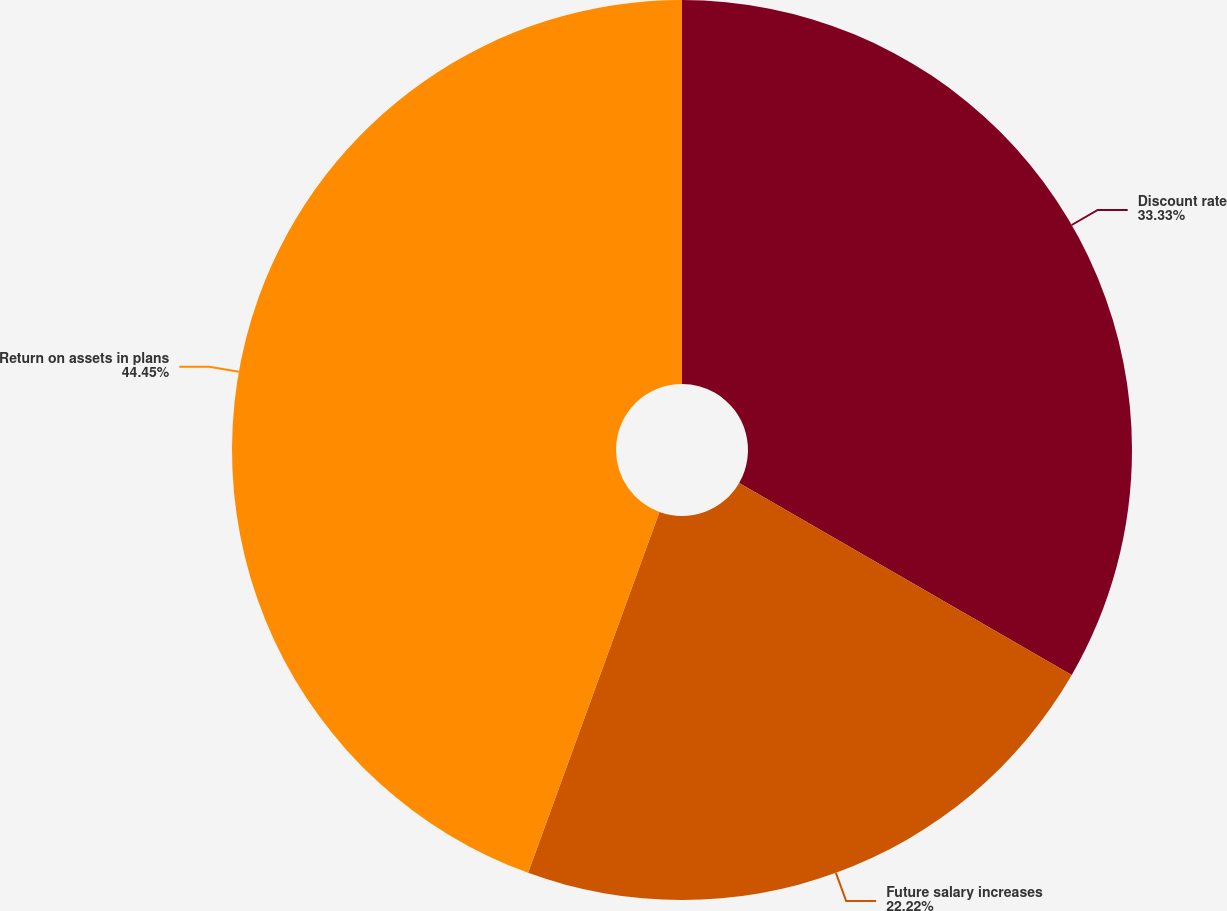Convert chart to OTSL. <chart><loc_0><loc_0><loc_500><loc_500><pie_chart><fcel>Discount rate<fcel>Future salary increases<fcel>Return on assets in plans<nl><fcel>33.33%<fcel>22.22%<fcel>44.44%<nl></chart> 